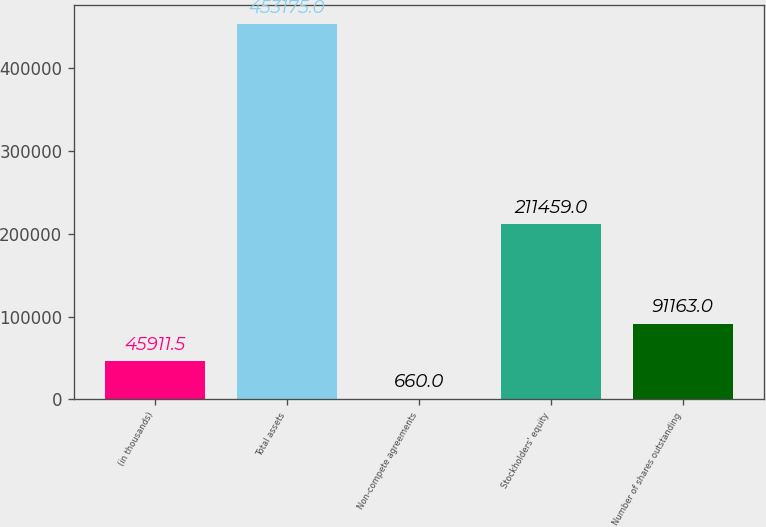Convert chart. <chart><loc_0><loc_0><loc_500><loc_500><bar_chart><fcel>(in thousands)<fcel>Total assets<fcel>Non-compete agreements<fcel>Stockholders' equity<fcel>Number of shares outstanding<nl><fcel>45911.5<fcel>453175<fcel>660<fcel>211459<fcel>91163<nl></chart> 